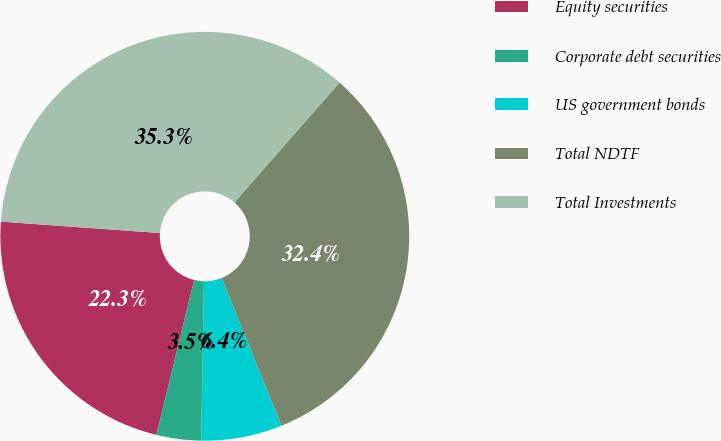<chart> <loc_0><loc_0><loc_500><loc_500><pie_chart><fcel>Equity securities<fcel>Corporate debt securities<fcel>US government bonds<fcel>Total NDTF<fcel>Total Investments<nl><fcel>22.34%<fcel>3.52%<fcel>6.41%<fcel>32.42%<fcel>35.31%<nl></chart> 